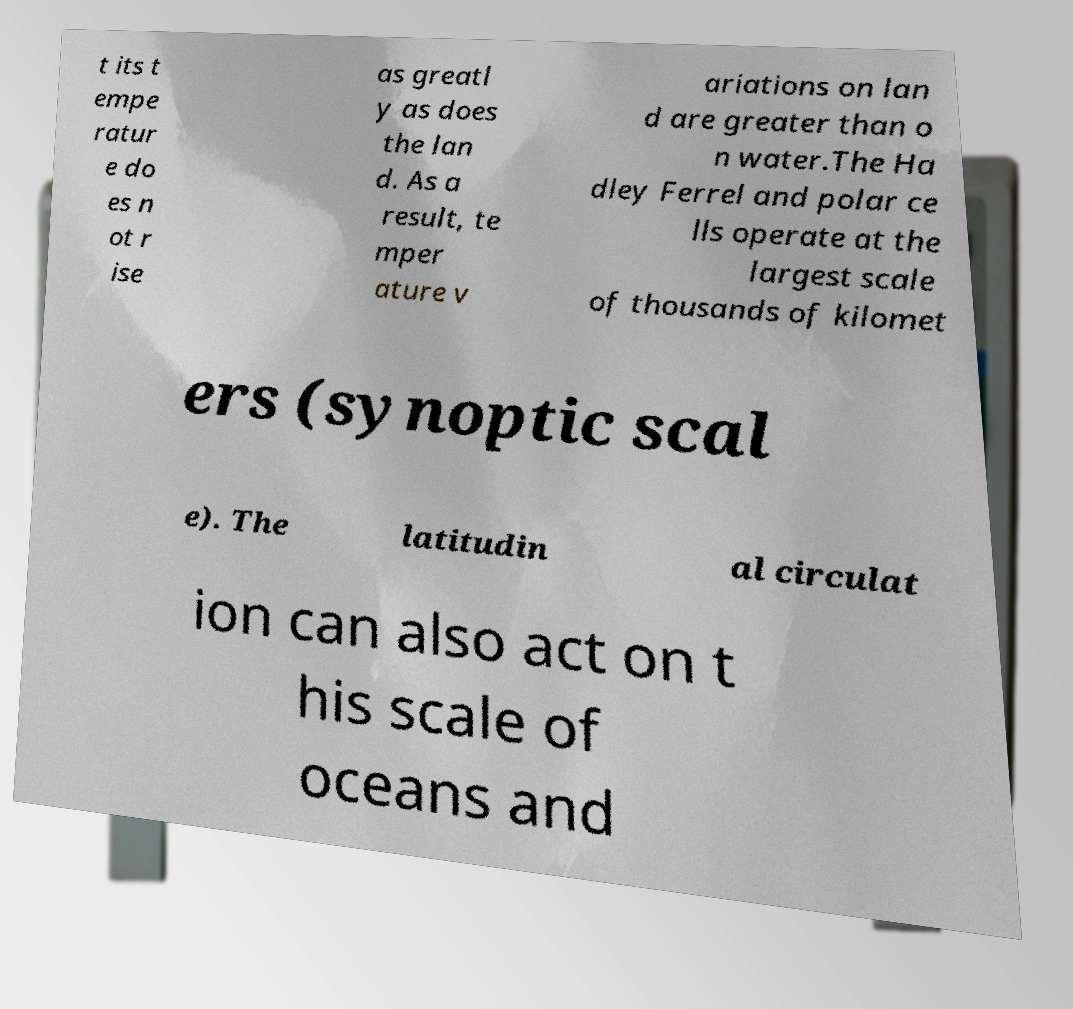Can you accurately transcribe the text from the provided image for me? t its t empe ratur e do es n ot r ise as greatl y as does the lan d. As a result, te mper ature v ariations on lan d are greater than o n water.The Ha dley Ferrel and polar ce lls operate at the largest scale of thousands of kilomet ers (synoptic scal e). The latitudin al circulat ion can also act on t his scale of oceans and 